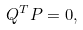Convert formula to latex. <formula><loc_0><loc_0><loc_500><loc_500>{ Q } ^ { T } { P } = 0 ,</formula> 